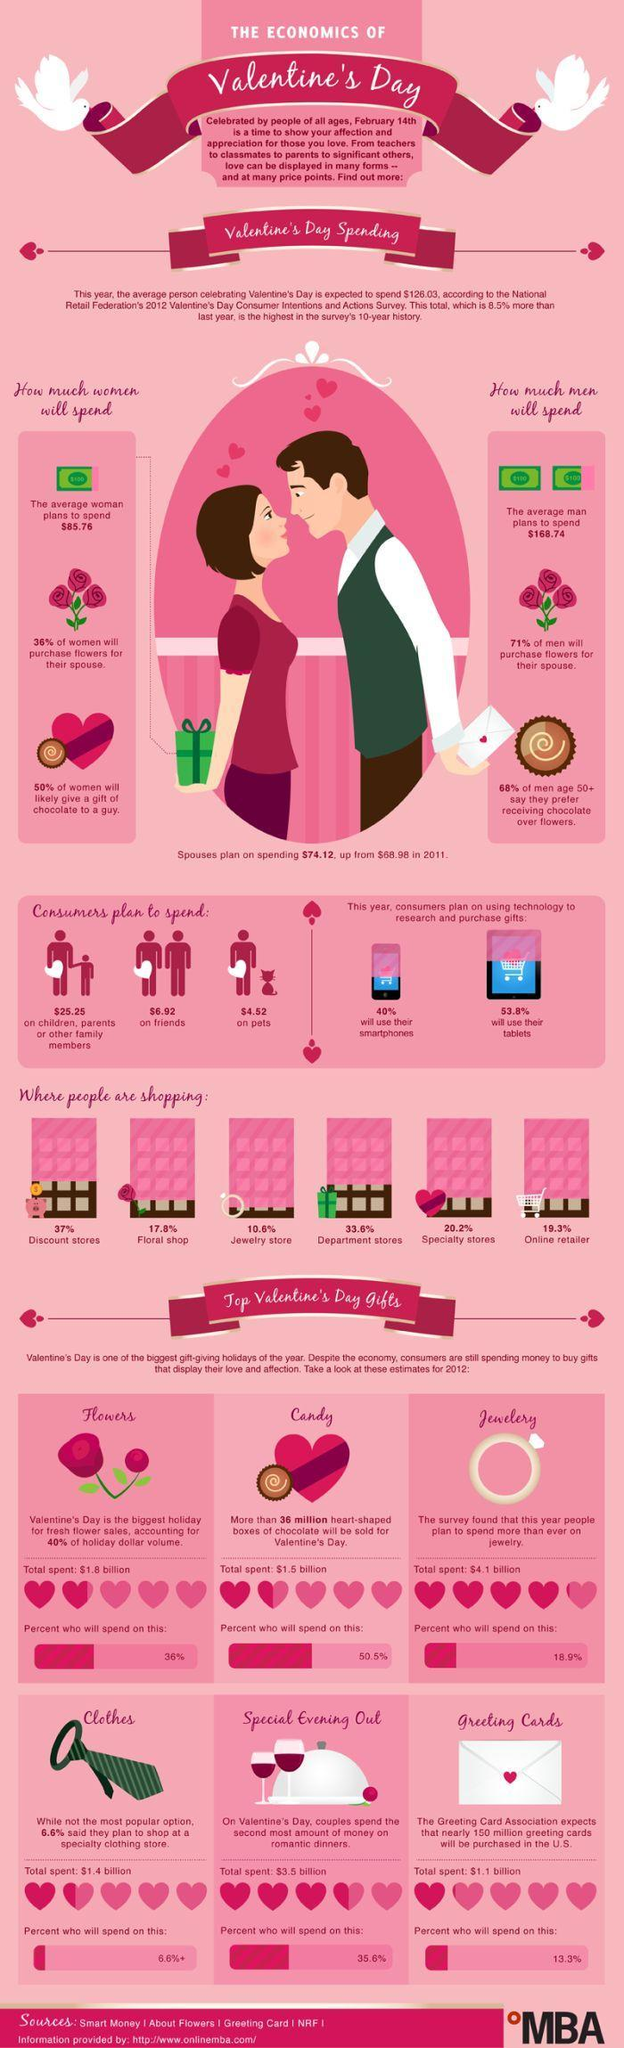What gift did most men prefer over flowers?
Answer the question with a short phrase. Chocolate What percentage of people will gift clothes for Valentine's day? 6.6% What percentage of people will gift candies for Valentine's day? 50.5% What was the total expenditure on romantic dinners for Valentine's day? $3.5 billion What percent of consumers will use tablets to purchase gifts for the loved ones? 53.8% What percentage of people are shopping online for valentine gifts? 19.3% How much are consumers planning to spend on their pets for valentine's day? $4.52 What percentage of people are shopping from floral shops? 17.8% What percent of the consumers will use their smartphones to purchase gifts for the loved ones? 40% How many options of shops/stores are shown here? 6 How much do consumers plan to spend on their friends? $6.92 Where are majority of the people shopping from, for Valentine's day? Discount stores How much more are spouses planning on spending in 2012, than in the previous year (in dollars)? 5.14 What is the colour of the neck tie shown in the image - red, pink, green or white? Green On which valentine gift was the highest amount spent by consumers, in 2012? Jewelery What is the total spent on heart shaped boxes of candies on valentine's day? $1.5 billion 